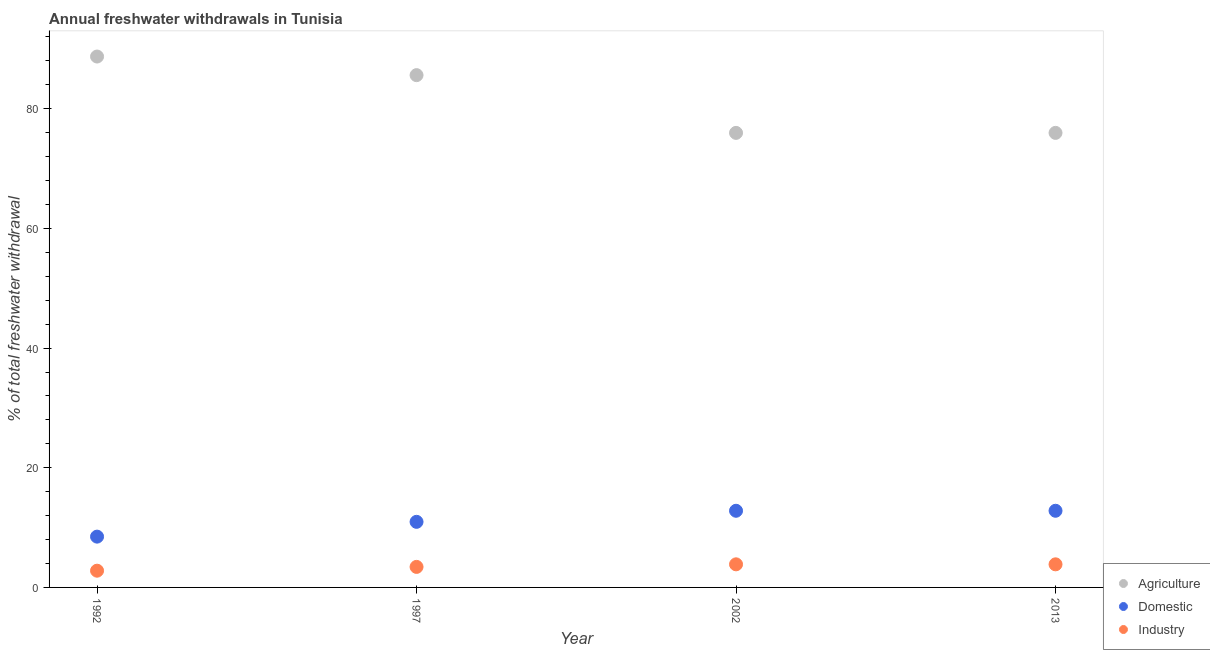What is the percentage of freshwater withdrawal for domestic purposes in 1992?
Provide a succinct answer. 8.49. Across all years, what is the maximum percentage of freshwater withdrawal for domestic purposes?
Your answer should be very brief. 12.81. Across all years, what is the minimum percentage of freshwater withdrawal for agriculture?
Give a very brief answer. 75.96. In which year was the percentage of freshwater withdrawal for industry maximum?
Provide a succinct answer. 2002. In which year was the percentage of freshwater withdrawal for domestic purposes minimum?
Your answer should be very brief. 1992. What is the total percentage of freshwater withdrawal for domestic purposes in the graph?
Offer a terse response. 45.07. What is the difference between the percentage of freshwater withdrawal for domestic purposes in 2002 and that in 2013?
Provide a short and direct response. 0. What is the difference between the percentage of freshwater withdrawal for agriculture in 1997 and the percentage of freshwater withdrawal for industry in 2002?
Offer a very short reply. 81.75. What is the average percentage of freshwater withdrawal for domestic purposes per year?
Your response must be concise. 11.27. In the year 1992, what is the difference between the percentage of freshwater withdrawal for agriculture and percentage of freshwater withdrawal for domestic purposes?
Give a very brief answer. 80.23. In how many years, is the percentage of freshwater withdrawal for domestic purposes greater than 32 %?
Provide a short and direct response. 0. What is the ratio of the percentage of freshwater withdrawal for domestic purposes in 1997 to that in 2002?
Ensure brevity in your answer.  0.86. What is the difference between the highest and the lowest percentage of freshwater withdrawal for domestic purposes?
Ensure brevity in your answer.  4.32. In how many years, is the percentage of freshwater withdrawal for agriculture greater than the average percentage of freshwater withdrawal for agriculture taken over all years?
Offer a terse response. 2. Is the sum of the percentage of freshwater withdrawal for agriculture in 2002 and 2013 greater than the maximum percentage of freshwater withdrawal for domestic purposes across all years?
Offer a terse response. Yes. What is the difference between two consecutive major ticks on the Y-axis?
Keep it short and to the point. 20. Does the graph contain grids?
Keep it short and to the point. No. How many legend labels are there?
Offer a terse response. 3. How are the legend labels stacked?
Provide a short and direct response. Vertical. What is the title of the graph?
Offer a very short reply. Annual freshwater withdrawals in Tunisia. What is the label or title of the X-axis?
Your response must be concise. Year. What is the label or title of the Y-axis?
Keep it short and to the point. % of total freshwater withdrawal. What is the % of total freshwater withdrawal of Agriculture in 1992?
Keep it short and to the point. 88.72. What is the % of total freshwater withdrawal in Domestic in 1992?
Ensure brevity in your answer.  8.49. What is the % of total freshwater withdrawal of Industry in 1992?
Give a very brief answer. 2.8. What is the % of total freshwater withdrawal of Agriculture in 1997?
Your response must be concise. 85.61. What is the % of total freshwater withdrawal in Domestic in 1997?
Make the answer very short. 10.96. What is the % of total freshwater withdrawal in Industry in 1997?
Offer a very short reply. 3.43. What is the % of total freshwater withdrawal of Agriculture in 2002?
Make the answer very short. 75.96. What is the % of total freshwater withdrawal of Domestic in 2002?
Make the answer very short. 12.81. What is the % of total freshwater withdrawal of Industry in 2002?
Ensure brevity in your answer.  3.86. What is the % of total freshwater withdrawal in Agriculture in 2013?
Make the answer very short. 75.96. What is the % of total freshwater withdrawal of Domestic in 2013?
Provide a succinct answer. 12.81. What is the % of total freshwater withdrawal of Industry in 2013?
Offer a terse response. 3.86. Across all years, what is the maximum % of total freshwater withdrawal of Agriculture?
Offer a very short reply. 88.72. Across all years, what is the maximum % of total freshwater withdrawal in Domestic?
Make the answer very short. 12.81. Across all years, what is the maximum % of total freshwater withdrawal in Industry?
Provide a succinct answer. 3.86. Across all years, what is the minimum % of total freshwater withdrawal of Agriculture?
Your response must be concise. 75.96. Across all years, what is the minimum % of total freshwater withdrawal in Domestic?
Ensure brevity in your answer.  8.49. Across all years, what is the minimum % of total freshwater withdrawal of Industry?
Your answer should be compact. 2.8. What is the total % of total freshwater withdrawal of Agriculture in the graph?
Your answer should be compact. 326.25. What is the total % of total freshwater withdrawal of Domestic in the graph?
Keep it short and to the point. 45.07. What is the total % of total freshwater withdrawal in Industry in the graph?
Make the answer very short. 13.95. What is the difference between the % of total freshwater withdrawal of Agriculture in 1992 and that in 1997?
Make the answer very short. 3.11. What is the difference between the % of total freshwater withdrawal of Domestic in 1992 and that in 1997?
Your answer should be very brief. -2.47. What is the difference between the % of total freshwater withdrawal of Industry in 1992 and that in 1997?
Offer a very short reply. -0.63. What is the difference between the % of total freshwater withdrawal of Agriculture in 1992 and that in 2002?
Ensure brevity in your answer.  12.76. What is the difference between the % of total freshwater withdrawal of Domestic in 1992 and that in 2002?
Your response must be concise. -4.32. What is the difference between the % of total freshwater withdrawal of Industry in 1992 and that in 2002?
Your answer should be very brief. -1.06. What is the difference between the % of total freshwater withdrawal in Agriculture in 1992 and that in 2013?
Make the answer very short. 12.76. What is the difference between the % of total freshwater withdrawal in Domestic in 1992 and that in 2013?
Give a very brief answer. -4.32. What is the difference between the % of total freshwater withdrawal of Industry in 1992 and that in 2013?
Provide a succinct answer. -1.06. What is the difference between the % of total freshwater withdrawal of Agriculture in 1997 and that in 2002?
Your answer should be very brief. 9.65. What is the difference between the % of total freshwater withdrawal of Domestic in 1997 and that in 2002?
Give a very brief answer. -1.85. What is the difference between the % of total freshwater withdrawal of Industry in 1997 and that in 2002?
Give a very brief answer. -0.43. What is the difference between the % of total freshwater withdrawal in Agriculture in 1997 and that in 2013?
Provide a short and direct response. 9.65. What is the difference between the % of total freshwater withdrawal of Domestic in 1997 and that in 2013?
Ensure brevity in your answer.  -1.85. What is the difference between the % of total freshwater withdrawal in Industry in 1997 and that in 2013?
Give a very brief answer. -0.43. What is the difference between the % of total freshwater withdrawal in Agriculture in 2002 and that in 2013?
Provide a succinct answer. 0. What is the difference between the % of total freshwater withdrawal in Agriculture in 1992 and the % of total freshwater withdrawal in Domestic in 1997?
Make the answer very short. 77.76. What is the difference between the % of total freshwater withdrawal of Agriculture in 1992 and the % of total freshwater withdrawal of Industry in 1997?
Offer a very short reply. 85.29. What is the difference between the % of total freshwater withdrawal of Domestic in 1992 and the % of total freshwater withdrawal of Industry in 1997?
Provide a short and direct response. 5.06. What is the difference between the % of total freshwater withdrawal of Agriculture in 1992 and the % of total freshwater withdrawal of Domestic in 2002?
Offer a very short reply. 75.91. What is the difference between the % of total freshwater withdrawal of Agriculture in 1992 and the % of total freshwater withdrawal of Industry in 2002?
Keep it short and to the point. 84.86. What is the difference between the % of total freshwater withdrawal of Domestic in 1992 and the % of total freshwater withdrawal of Industry in 2002?
Keep it short and to the point. 4.63. What is the difference between the % of total freshwater withdrawal in Agriculture in 1992 and the % of total freshwater withdrawal in Domestic in 2013?
Your answer should be compact. 75.91. What is the difference between the % of total freshwater withdrawal of Agriculture in 1992 and the % of total freshwater withdrawal of Industry in 2013?
Your answer should be very brief. 84.86. What is the difference between the % of total freshwater withdrawal of Domestic in 1992 and the % of total freshwater withdrawal of Industry in 2013?
Offer a very short reply. 4.63. What is the difference between the % of total freshwater withdrawal in Agriculture in 1997 and the % of total freshwater withdrawal in Domestic in 2002?
Offer a very short reply. 72.8. What is the difference between the % of total freshwater withdrawal in Agriculture in 1997 and the % of total freshwater withdrawal in Industry in 2002?
Provide a short and direct response. 81.75. What is the difference between the % of total freshwater withdrawal of Domestic in 1997 and the % of total freshwater withdrawal of Industry in 2002?
Your response must be concise. 7.1. What is the difference between the % of total freshwater withdrawal in Agriculture in 1997 and the % of total freshwater withdrawal in Domestic in 2013?
Provide a succinct answer. 72.8. What is the difference between the % of total freshwater withdrawal of Agriculture in 1997 and the % of total freshwater withdrawal of Industry in 2013?
Offer a very short reply. 81.75. What is the difference between the % of total freshwater withdrawal of Agriculture in 2002 and the % of total freshwater withdrawal of Domestic in 2013?
Provide a succinct answer. 63.15. What is the difference between the % of total freshwater withdrawal in Agriculture in 2002 and the % of total freshwater withdrawal in Industry in 2013?
Your response must be concise. 72.1. What is the difference between the % of total freshwater withdrawal in Domestic in 2002 and the % of total freshwater withdrawal in Industry in 2013?
Offer a very short reply. 8.95. What is the average % of total freshwater withdrawal of Agriculture per year?
Give a very brief answer. 81.56. What is the average % of total freshwater withdrawal in Domestic per year?
Your response must be concise. 11.27. What is the average % of total freshwater withdrawal of Industry per year?
Make the answer very short. 3.49. In the year 1992, what is the difference between the % of total freshwater withdrawal in Agriculture and % of total freshwater withdrawal in Domestic?
Offer a terse response. 80.23. In the year 1992, what is the difference between the % of total freshwater withdrawal in Agriculture and % of total freshwater withdrawal in Industry?
Make the answer very short. 85.92. In the year 1992, what is the difference between the % of total freshwater withdrawal in Domestic and % of total freshwater withdrawal in Industry?
Keep it short and to the point. 5.69. In the year 1997, what is the difference between the % of total freshwater withdrawal in Agriculture and % of total freshwater withdrawal in Domestic?
Your response must be concise. 74.65. In the year 1997, what is the difference between the % of total freshwater withdrawal of Agriculture and % of total freshwater withdrawal of Industry?
Ensure brevity in your answer.  82.18. In the year 1997, what is the difference between the % of total freshwater withdrawal in Domestic and % of total freshwater withdrawal in Industry?
Your answer should be compact. 7.53. In the year 2002, what is the difference between the % of total freshwater withdrawal of Agriculture and % of total freshwater withdrawal of Domestic?
Offer a terse response. 63.15. In the year 2002, what is the difference between the % of total freshwater withdrawal of Agriculture and % of total freshwater withdrawal of Industry?
Provide a succinct answer. 72.1. In the year 2002, what is the difference between the % of total freshwater withdrawal in Domestic and % of total freshwater withdrawal in Industry?
Provide a succinct answer. 8.95. In the year 2013, what is the difference between the % of total freshwater withdrawal in Agriculture and % of total freshwater withdrawal in Domestic?
Your response must be concise. 63.15. In the year 2013, what is the difference between the % of total freshwater withdrawal in Agriculture and % of total freshwater withdrawal in Industry?
Keep it short and to the point. 72.1. In the year 2013, what is the difference between the % of total freshwater withdrawal of Domestic and % of total freshwater withdrawal of Industry?
Offer a terse response. 8.95. What is the ratio of the % of total freshwater withdrawal of Agriculture in 1992 to that in 1997?
Offer a terse response. 1.04. What is the ratio of the % of total freshwater withdrawal of Domestic in 1992 to that in 1997?
Provide a short and direct response. 0.77. What is the ratio of the % of total freshwater withdrawal in Industry in 1992 to that in 1997?
Provide a succinct answer. 0.82. What is the ratio of the % of total freshwater withdrawal of Agriculture in 1992 to that in 2002?
Offer a terse response. 1.17. What is the ratio of the % of total freshwater withdrawal in Domestic in 1992 to that in 2002?
Make the answer very short. 0.66. What is the ratio of the % of total freshwater withdrawal of Industry in 1992 to that in 2002?
Provide a succinct answer. 0.72. What is the ratio of the % of total freshwater withdrawal of Agriculture in 1992 to that in 2013?
Keep it short and to the point. 1.17. What is the ratio of the % of total freshwater withdrawal of Domestic in 1992 to that in 2013?
Make the answer very short. 0.66. What is the ratio of the % of total freshwater withdrawal in Industry in 1992 to that in 2013?
Ensure brevity in your answer.  0.72. What is the ratio of the % of total freshwater withdrawal in Agriculture in 1997 to that in 2002?
Your answer should be very brief. 1.13. What is the ratio of the % of total freshwater withdrawal in Domestic in 1997 to that in 2002?
Your answer should be very brief. 0.86. What is the ratio of the % of total freshwater withdrawal of Industry in 1997 to that in 2002?
Provide a short and direct response. 0.89. What is the ratio of the % of total freshwater withdrawal of Agriculture in 1997 to that in 2013?
Keep it short and to the point. 1.13. What is the ratio of the % of total freshwater withdrawal of Domestic in 1997 to that in 2013?
Your answer should be very brief. 0.86. What is the ratio of the % of total freshwater withdrawal in Industry in 1997 to that in 2013?
Keep it short and to the point. 0.89. What is the ratio of the % of total freshwater withdrawal of Industry in 2002 to that in 2013?
Offer a terse response. 1. What is the difference between the highest and the second highest % of total freshwater withdrawal of Agriculture?
Offer a terse response. 3.11. What is the difference between the highest and the second highest % of total freshwater withdrawal of Industry?
Provide a succinct answer. 0. What is the difference between the highest and the lowest % of total freshwater withdrawal in Agriculture?
Offer a very short reply. 12.76. What is the difference between the highest and the lowest % of total freshwater withdrawal in Domestic?
Make the answer very short. 4.32. What is the difference between the highest and the lowest % of total freshwater withdrawal of Industry?
Offer a terse response. 1.06. 